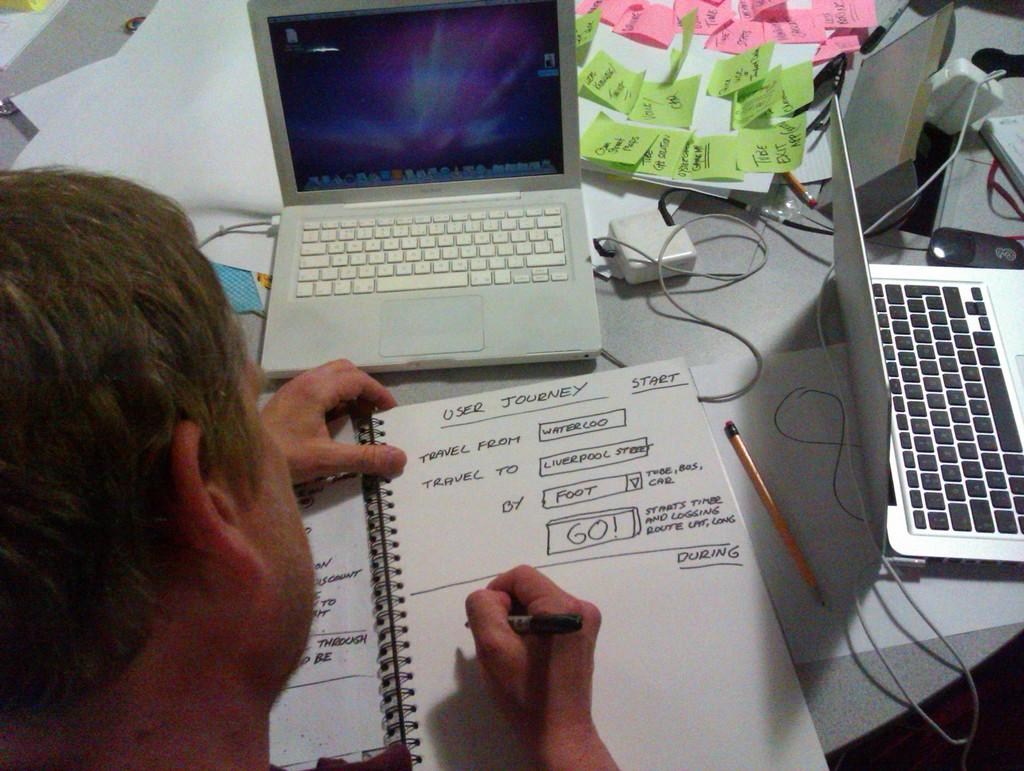<image>
Describe the image concisely. A man is writing about a user journey in a notepad while surrounded by laptops. 